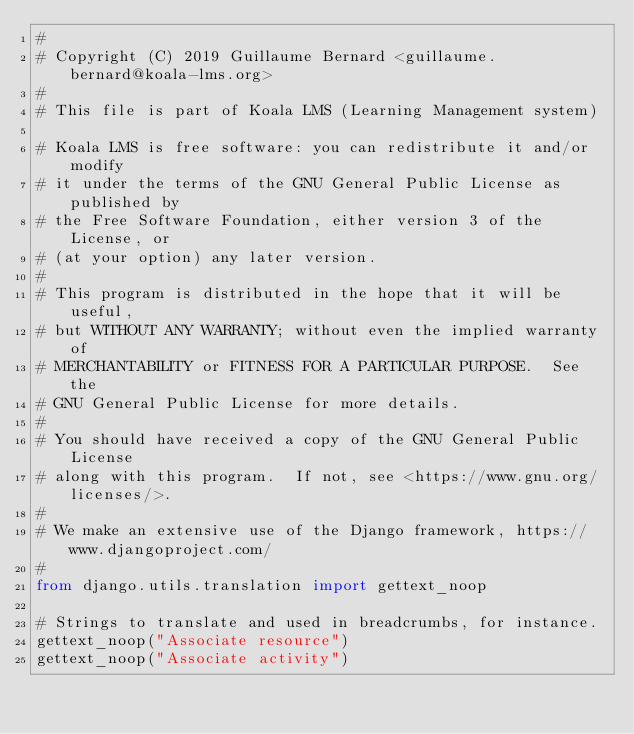<code> <loc_0><loc_0><loc_500><loc_500><_Python_>#
# Copyright (C) 2019 Guillaume Bernard <guillaume.bernard@koala-lms.org>
#
# This file is part of Koala LMS (Learning Management system)

# Koala LMS is free software: you can redistribute it and/or modify
# it under the terms of the GNU General Public License as published by
# the Free Software Foundation, either version 3 of the License, or
# (at your option) any later version.
#
# This program is distributed in the hope that it will be useful,
# but WITHOUT ANY WARRANTY; without even the implied warranty of
# MERCHANTABILITY or FITNESS FOR A PARTICULAR PURPOSE.  See the
# GNU General Public License for more details.
#
# You should have received a copy of the GNU General Public License
# along with this program.  If not, see <https://www.gnu.org/licenses/>.
#
# We make an extensive use of the Django framework, https://www.djangoproject.com/
#
from django.utils.translation import gettext_noop

# Strings to translate and used in breadcrumbs, for instance.
gettext_noop("Associate resource")
gettext_noop("Associate activity")
</code> 